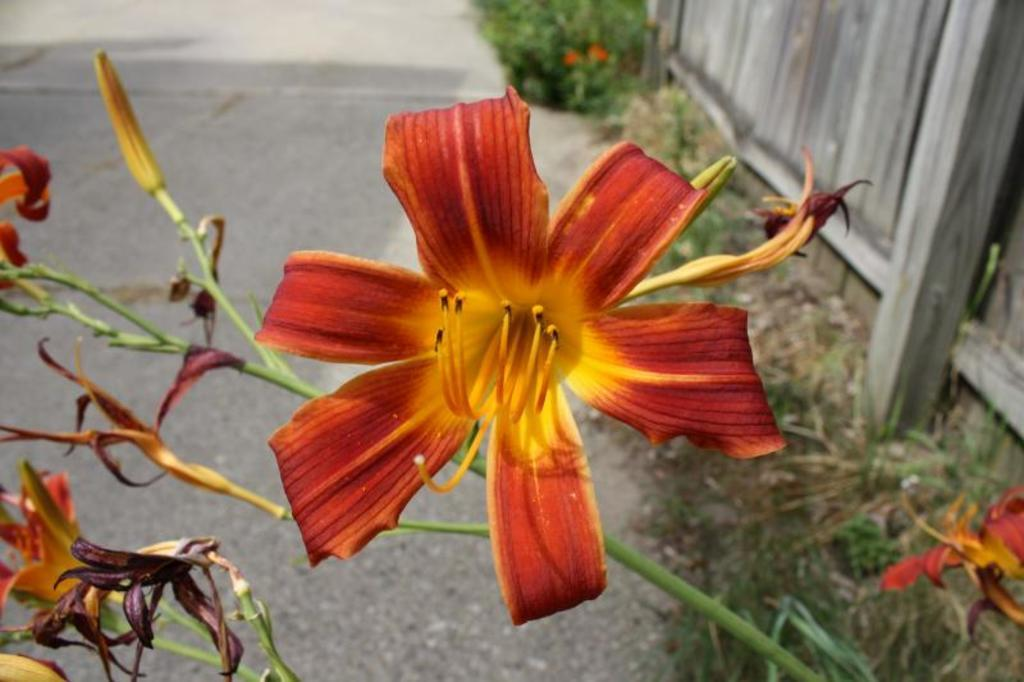What type of plant can be seen in the image? There is a flower plant in the image. What else is visible in the image besides the flower plant? There is a road, plants on the left side of the road, and a fence in the image. Is there any quicksand visible in the image? No, there is no quicksand present in the image. What type of umbrella is being used by the flower plant in the image? There is no umbrella present in the image, as it features a flower plant, a road, plants on the left side of the road, and a fence. 